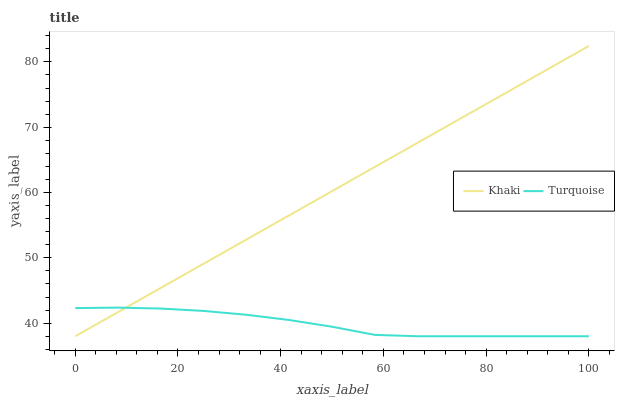Does Turquoise have the minimum area under the curve?
Answer yes or no. Yes. Does Khaki have the maximum area under the curve?
Answer yes or no. Yes. Does Khaki have the minimum area under the curve?
Answer yes or no. No. Is Khaki the smoothest?
Answer yes or no. Yes. Is Turquoise the roughest?
Answer yes or no. Yes. Is Khaki the roughest?
Answer yes or no. No. Does Turquoise have the lowest value?
Answer yes or no. Yes. Does Khaki have the highest value?
Answer yes or no. Yes. Does Turquoise intersect Khaki?
Answer yes or no. Yes. Is Turquoise less than Khaki?
Answer yes or no. No. Is Turquoise greater than Khaki?
Answer yes or no. No. 